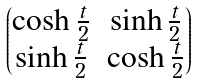<formula> <loc_0><loc_0><loc_500><loc_500>\begin{pmatrix} \cosh \frac { t } { 2 } & \sinh \frac { t } { 2 } \\ \sinh \frac { t } { 2 } & \cosh \frac { t } { 2 } \end{pmatrix}</formula> 